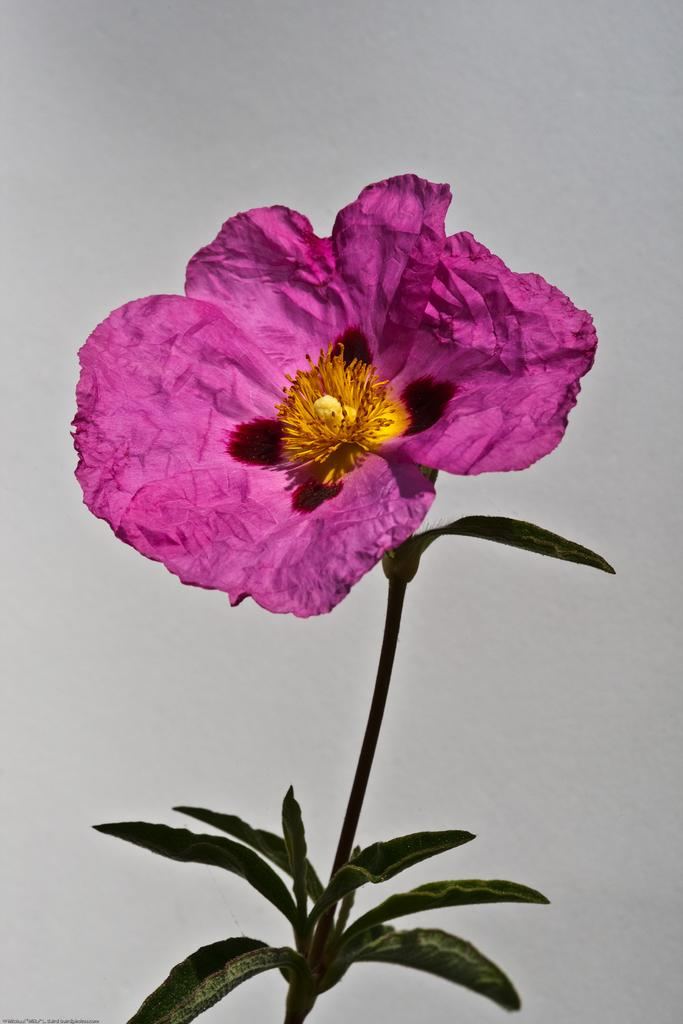What is the main subject of the image? There is a flower plant in the center of the image. What color is the background of the image? The background of the image is white. What type of feast is being prepared in the image? There is no feast or any indication of food preparation in the image; it features a flower plant in the center and a white background. 